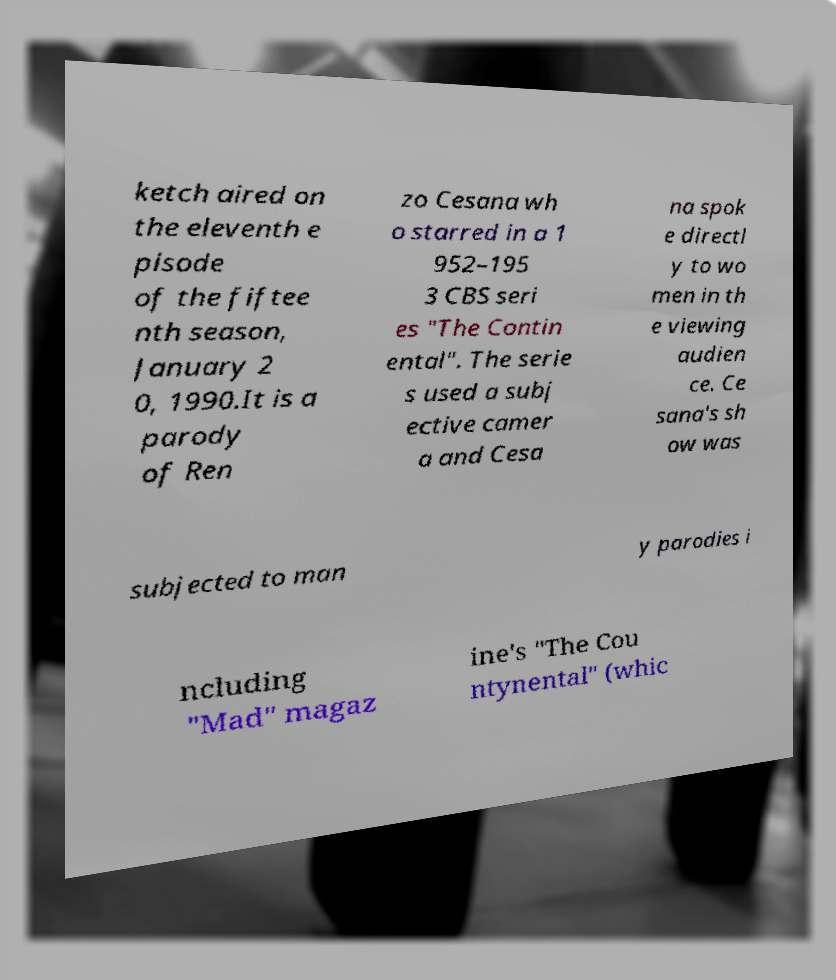I need the written content from this picture converted into text. Can you do that? ketch aired on the eleventh e pisode of the fiftee nth season, January 2 0, 1990.It is a parody of Ren zo Cesana wh o starred in a 1 952–195 3 CBS seri es "The Contin ental". The serie s used a subj ective camer a and Cesa na spok e directl y to wo men in th e viewing audien ce. Ce sana's sh ow was subjected to man y parodies i ncluding "Mad" magaz ine's "The Cou ntynental" (whic 